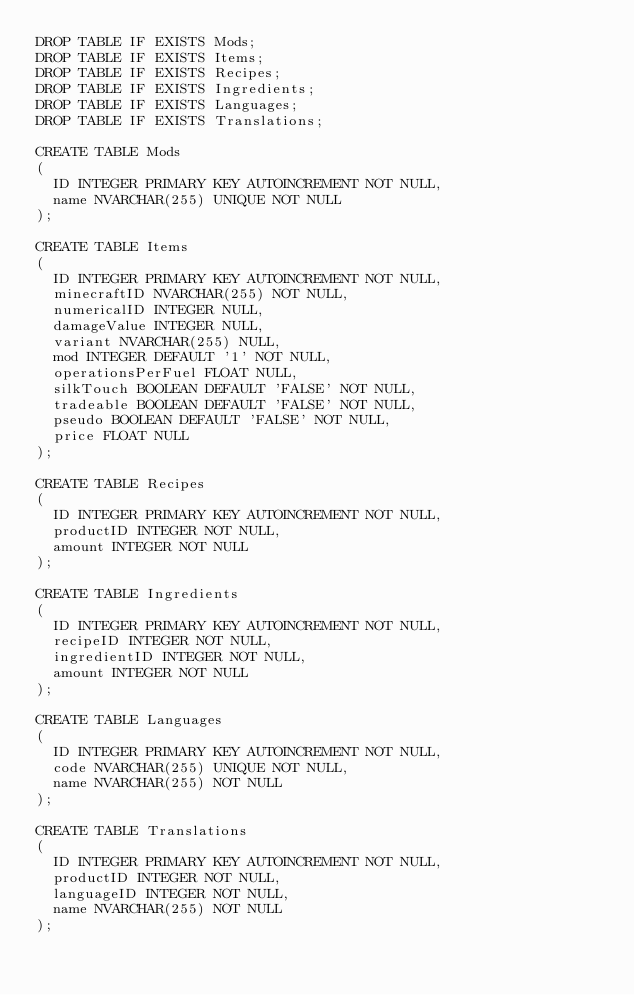Convert code to text. <code><loc_0><loc_0><loc_500><loc_500><_SQL_>DROP TABLE IF EXISTS Mods;
DROP TABLE IF EXISTS Items;
DROP TABLE IF EXISTS Recipes;
DROP TABLE IF EXISTS Ingredients;
DROP TABLE IF EXISTS Languages;
DROP TABLE IF EXISTS Translations;

CREATE TABLE Mods
(
  ID INTEGER PRIMARY KEY AUTOINCREMENT NOT NULL,
  name NVARCHAR(255) UNIQUE NOT NULL
);

CREATE TABLE Items
(
  ID INTEGER PRIMARY KEY AUTOINCREMENT NOT NULL,
  minecraftID NVARCHAR(255) NOT NULL,
  numericalID INTEGER NULL,
  damageValue INTEGER NULL,
  variant NVARCHAR(255) NULL,
  mod INTEGER DEFAULT '1' NOT NULL,
  operationsPerFuel FLOAT NULL,
  silkTouch BOOLEAN DEFAULT 'FALSE' NOT NULL,
  tradeable BOOLEAN DEFAULT 'FALSE' NOT NULL,
  pseudo BOOLEAN DEFAULT 'FALSE' NOT NULL,
  price FLOAT NULL
);

CREATE TABLE Recipes
(
  ID INTEGER PRIMARY KEY AUTOINCREMENT NOT NULL,
  productID INTEGER NOT NULL,
  amount INTEGER NOT NULL
);

CREATE TABLE Ingredients
(
  ID INTEGER PRIMARY KEY AUTOINCREMENT NOT NULL,
  recipeID INTEGER NOT NULL,
  ingredientID INTEGER NOT NULL,
  amount INTEGER NOT NULL
);

CREATE TABLE Languages
(
  ID INTEGER PRIMARY KEY AUTOINCREMENT NOT NULL,
  code NVARCHAR(255) UNIQUE NOT NULL,
  name NVARCHAR(255) NOT NULL
);

CREATE TABLE Translations
(
  ID INTEGER PRIMARY KEY AUTOINCREMENT NOT NULL,
  productID INTEGER NOT NULL,
  languageID INTEGER NOT NULL,
  name NVARCHAR(255) NOT NULL
);</code> 